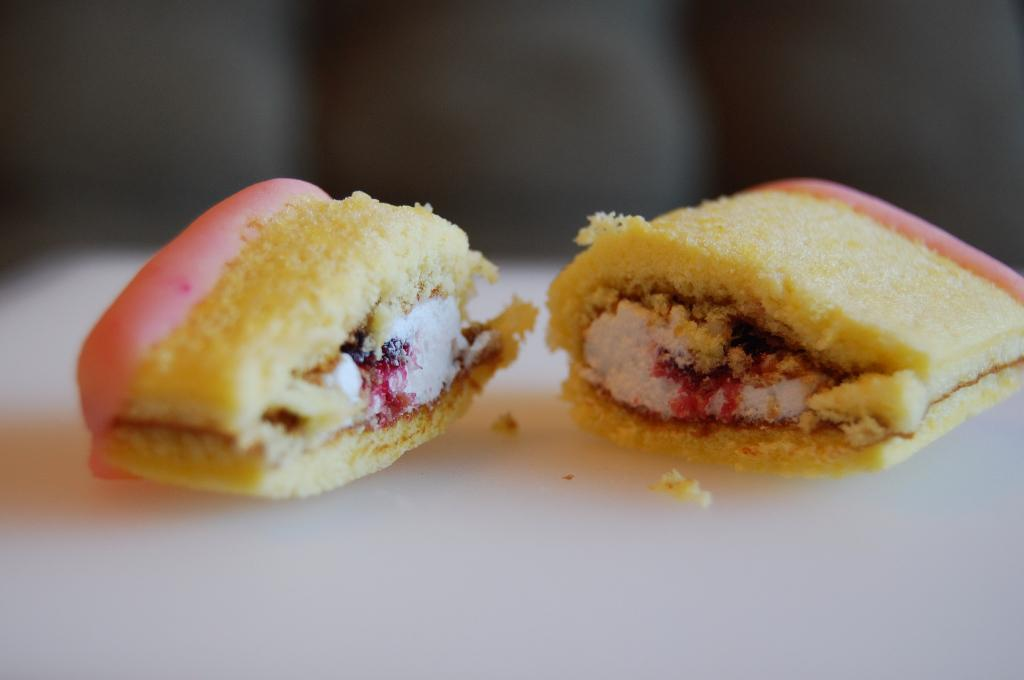What type of items can be seen on the surface in the image? There are food items on the surface in the image. What type of bead is used as a decoration on the food items in the image? There is no bead present on the food items in the image. What type of channel is visible in the image? There is no channel present in the image. 